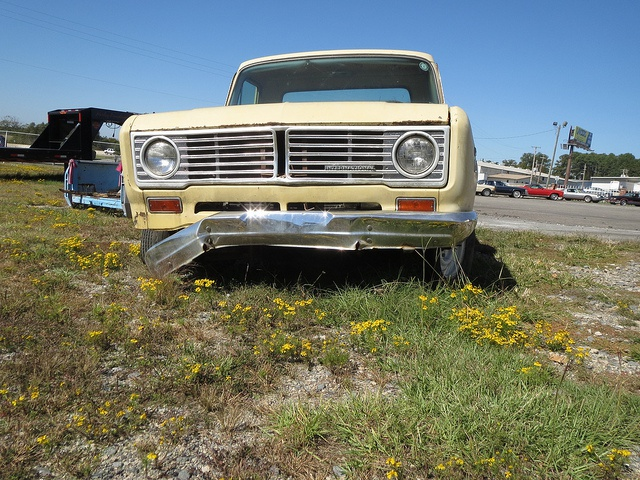Describe the objects in this image and their specific colors. I can see truck in gray, beige, black, and darkgray tones, car in gray, darkgray, white, and black tones, car in gray, black, and darkgray tones, car in gray, brown, and black tones, and car in gray, black, darkgray, and maroon tones in this image. 